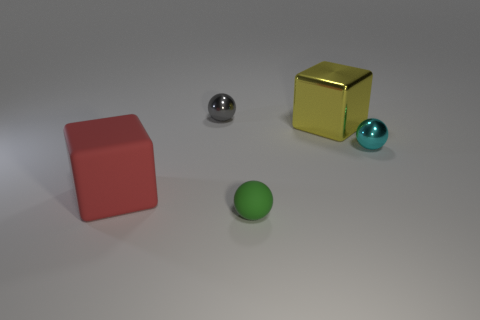There is another small metallic object that is the same shape as the cyan object; what is its color? gray 